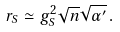Convert formula to latex. <formula><loc_0><loc_0><loc_500><loc_500>r _ { S } \simeq g _ { S } ^ { 2 } \sqrt { n } \sqrt { \alpha ^ { \prime } } \, .</formula> 